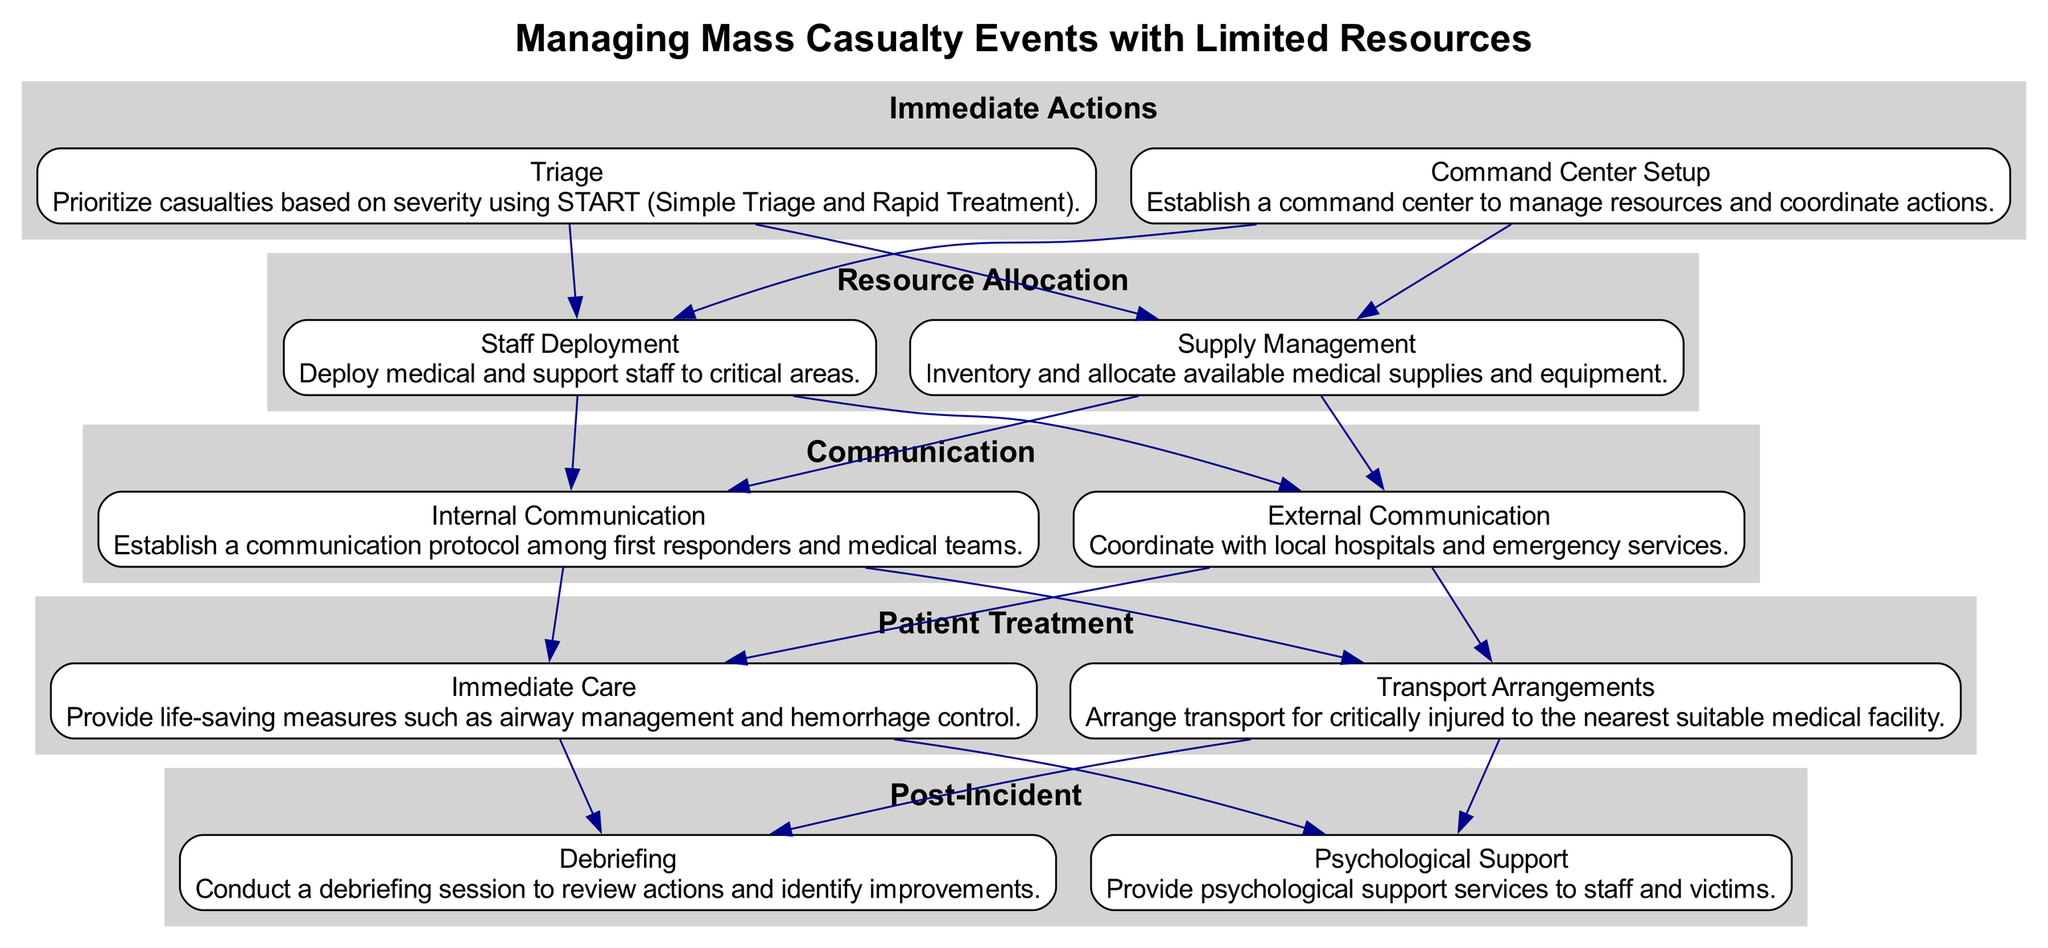What is the first action in the clinical pathway? The first action listed in the Immediate Actions category is Triage, which is used to prioritize casualties based on severity.
Answer: Triage How many categories are in the clinical pathway? There are five categories in the clinical pathway: Immediate Actions, Resource Allocation, Communication, Patient Treatment, and Post-Incident.
Answer: 5 What action comes after Supply Management? After Supply Management, the next action in the flow is Internal Communication, which establishes a communication protocol among response teams.
Answer: Internal Communication Which category includes psychological support services? The category that includes psychological support services is Post-Incident, which focuses on providing services to staff and victims after the incident.
Answer: Post-Incident What is the last step in the clinical pathway? The last step in the clinical pathway is Psychological Support, which aims to offer support services to those affected after the incident.
Answer: Psychological Support What two actions are included in the Patient Treatment category? The Patient Treatment category includes Immediate Care and Transport Arrangements, which focus on life-saving measures and transportation, respectively.
Answer: Immediate Care and Transport Arrangements Which two communication types are outlined in the diagram? The two types of communication outlined in the diagram are Internal Communication and External Communication, with each serving different coordination functions.
Answer: Internal Communication and External Communication How does the Resource Allocation category connect to the Patient Treatment category? The Resource Allocation category connects to the Patient Treatment category through the flow, indicating that after resource management, actions related to patient care follow.
Answer: Through the flow of actions What is the purpose of command center setup? The purpose of command center setup is to establish a location for managing resources and coordinating actions during a mass casualty event.
Answer: Manage resources and coordinate actions 